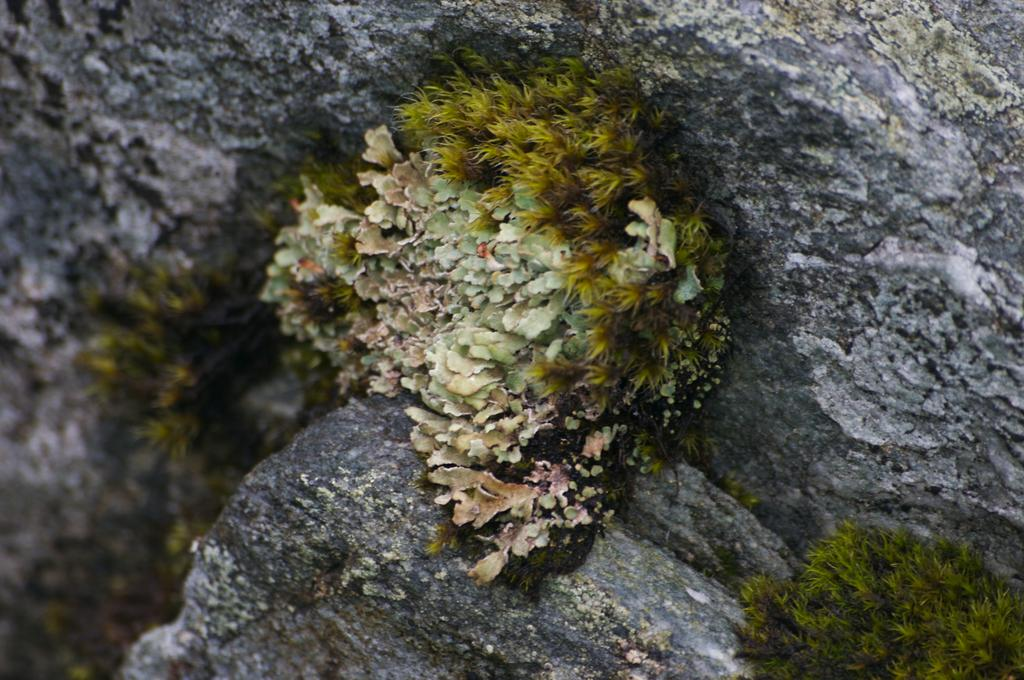What is the main subject of the image? The main subject of the image is a plant on a rock. Are there any other plants visible in the image? Yes, there is another plant in the bottom right of the image. What type of record is being played by the plant in the image? There is no record present in the image, as it features plants on a rock and another plant in the bottom right. 